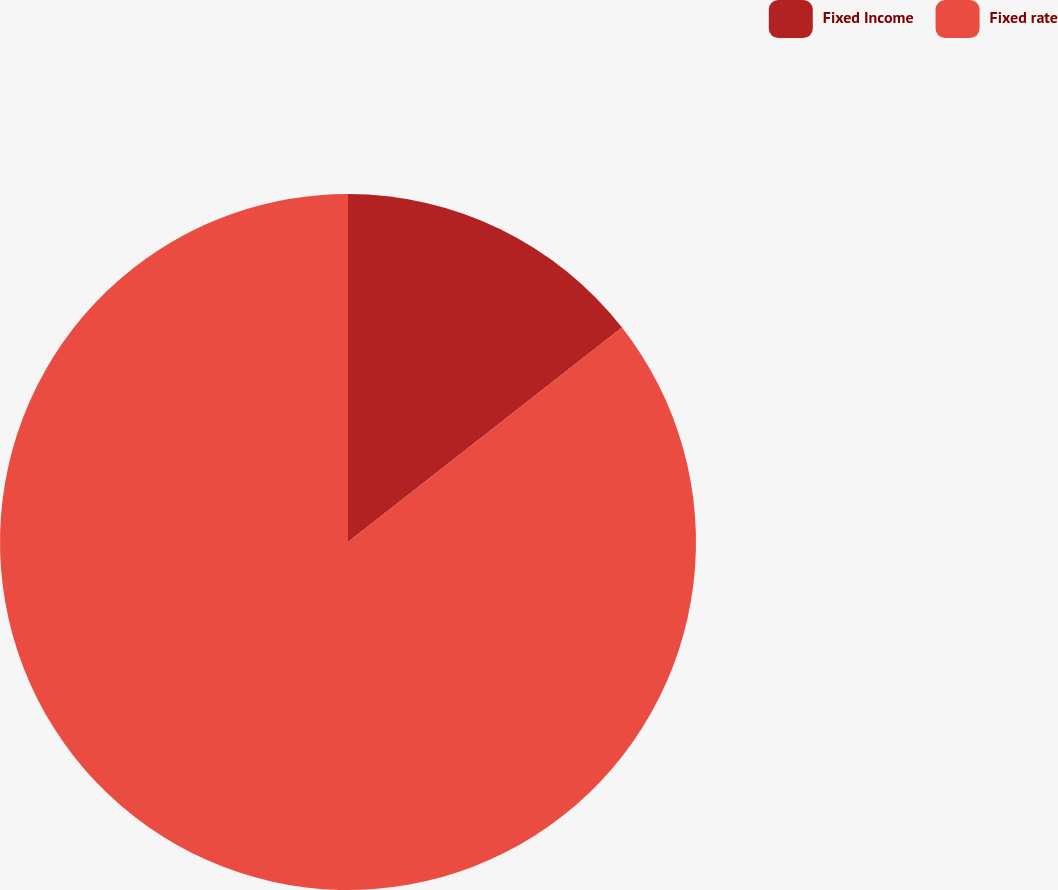<chart> <loc_0><loc_0><loc_500><loc_500><pie_chart><fcel>Fixed Income<fcel>Fixed rate<nl><fcel>14.43%<fcel>85.57%<nl></chart> 